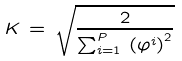Convert formula to latex. <formula><loc_0><loc_0><loc_500><loc_500>K \, = \, \sqrt { \frac { 2 } { \sum _ { i = 1 } ^ { P } \, \left ( \varphi ^ { i } \right ) ^ { 2 } } }</formula> 